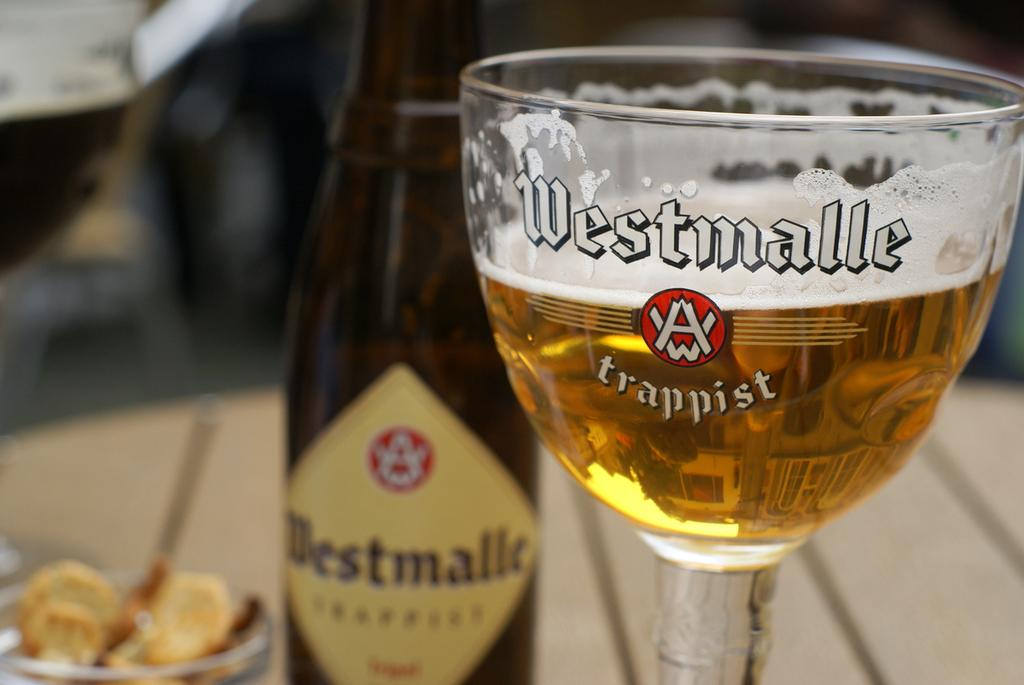Provide a one-sentence caption for the provided image. A glass of beer has Westmalle Trappist printed on it. 